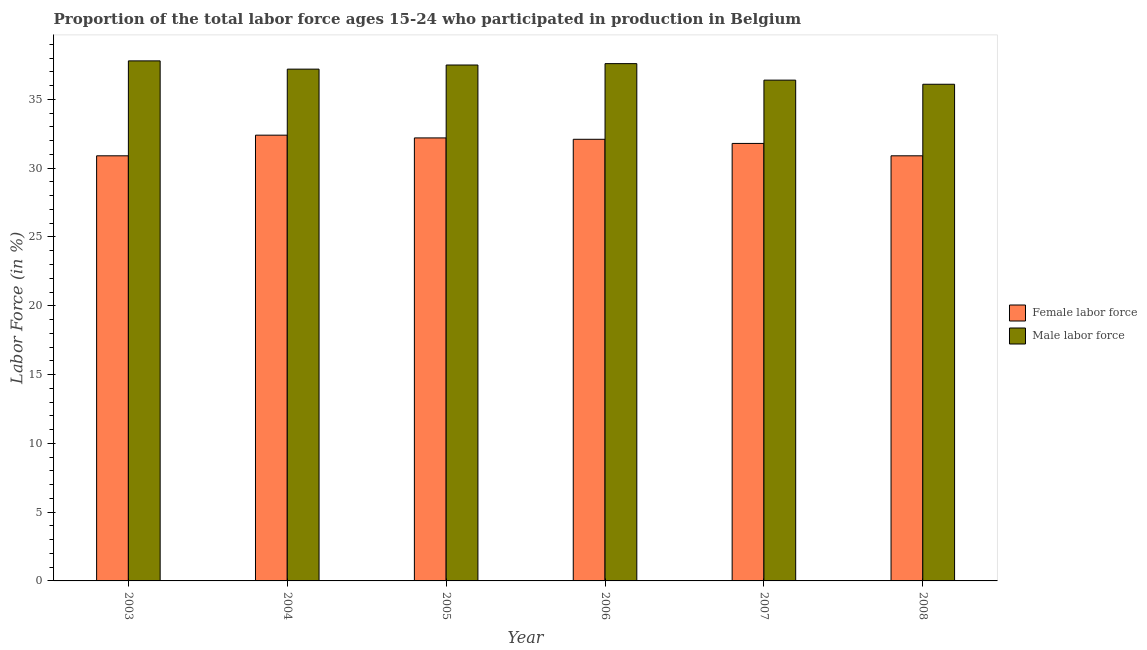How many groups of bars are there?
Provide a short and direct response. 6. Are the number of bars per tick equal to the number of legend labels?
Make the answer very short. Yes. Are the number of bars on each tick of the X-axis equal?
Ensure brevity in your answer.  Yes. How many bars are there on the 3rd tick from the left?
Keep it short and to the point. 2. What is the label of the 6th group of bars from the left?
Provide a short and direct response. 2008. In how many cases, is the number of bars for a given year not equal to the number of legend labels?
Offer a terse response. 0. What is the percentage of male labour force in 2004?
Offer a terse response. 37.2. Across all years, what is the maximum percentage of female labor force?
Keep it short and to the point. 32.4. Across all years, what is the minimum percentage of male labour force?
Make the answer very short. 36.1. In which year was the percentage of male labour force maximum?
Make the answer very short. 2003. In which year was the percentage of female labor force minimum?
Keep it short and to the point. 2003. What is the total percentage of female labor force in the graph?
Your answer should be very brief. 190.3. What is the difference between the percentage of female labor force in 2004 and that in 2005?
Make the answer very short. 0.2. What is the difference between the percentage of female labor force in 2004 and the percentage of male labour force in 2007?
Make the answer very short. 0.6. What is the average percentage of male labour force per year?
Your answer should be very brief. 37.1. In how many years, is the percentage of male labour force greater than 17 %?
Keep it short and to the point. 6. What is the ratio of the percentage of male labour force in 2005 to that in 2007?
Make the answer very short. 1.03. Is the percentage of male labour force in 2003 less than that in 2007?
Give a very brief answer. No. Is the difference between the percentage of female labor force in 2004 and 2006 greater than the difference between the percentage of male labour force in 2004 and 2006?
Provide a short and direct response. No. What is the difference between the highest and the second highest percentage of male labour force?
Your answer should be compact. 0.2. What is the difference between the highest and the lowest percentage of female labor force?
Ensure brevity in your answer.  1.5. Is the sum of the percentage of female labor force in 2004 and 2005 greater than the maximum percentage of male labour force across all years?
Give a very brief answer. Yes. What does the 1st bar from the left in 2005 represents?
Make the answer very short. Female labor force. What does the 1st bar from the right in 2007 represents?
Your answer should be very brief. Male labor force. Are all the bars in the graph horizontal?
Offer a terse response. No. Does the graph contain grids?
Ensure brevity in your answer.  No. Where does the legend appear in the graph?
Your response must be concise. Center right. How many legend labels are there?
Make the answer very short. 2. How are the legend labels stacked?
Provide a short and direct response. Vertical. What is the title of the graph?
Provide a short and direct response. Proportion of the total labor force ages 15-24 who participated in production in Belgium. What is the Labor Force (in %) in Female labor force in 2003?
Offer a very short reply. 30.9. What is the Labor Force (in %) in Male labor force in 2003?
Your answer should be very brief. 37.8. What is the Labor Force (in %) in Female labor force in 2004?
Offer a terse response. 32.4. What is the Labor Force (in %) in Male labor force in 2004?
Offer a terse response. 37.2. What is the Labor Force (in %) of Female labor force in 2005?
Your answer should be very brief. 32.2. What is the Labor Force (in %) of Male labor force in 2005?
Provide a short and direct response. 37.5. What is the Labor Force (in %) in Female labor force in 2006?
Give a very brief answer. 32.1. What is the Labor Force (in %) in Male labor force in 2006?
Your answer should be compact. 37.6. What is the Labor Force (in %) in Female labor force in 2007?
Provide a short and direct response. 31.8. What is the Labor Force (in %) of Male labor force in 2007?
Give a very brief answer. 36.4. What is the Labor Force (in %) in Female labor force in 2008?
Keep it short and to the point. 30.9. What is the Labor Force (in %) in Male labor force in 2008?
Your response must be concise. 36.1. Across all years, what is the maximum Labor Force (in %) in Female labor force?
Provide a succinct answer. 32.4. Across all years, what is the maximum Labor Force (in %) of Male labor force?
Provide a succinct answer. 37.8. Across all years, what is the minimum Labor Force (in %) of Female labor force?
Offer a very short reply. 30.9. Across all years, what is the minimum Labor Force (in %) of Male labor force?
Ensure brevity in your answer.  36.1. What is the total Labor Force (in %) in Female labor force in the graph?
Your answer should be compact. 190.3. What is the total Labor Force (in %) in Male labor force in the graph?
Make the answer very short. 222.6. What is the difference between the Labor Force (in %) of Female labor force in 2003 and that in 2004?
Keep it short and to the point. -1.5. What is the difference between the Labor Force (in %) in Male labor force in 2003 and that in 2004?
Provide a short and direct response. 0.6. What is the difference between the Labor Force (in %) of Female labor force in 2003 and that in 2006?
Your answer should be very brief. -1.2. What is the difference between the Labor Force (in %) of Female labor force in 2003 and that in 2008?
Keep it short and to the point. 0. What is the difference between the Labor Force (in %) of Male labor force in 2003 and that in 2008?
Ensure brevity in your answer.  1.7. What is the difference between the Labor Force (in %) of Male labor force in 2004 and that in 2006?
Keep it short and to the point. -0.4. What is the difference between the Labor Force (in %) in Female labor force in 2004 and that in 2007?
Your answer should be compact. 0.6. What is the difference between the Labor Force (in %) of Male labor force in 2004 and that in 2008?
Keep it short and to the point. 1.1. What is the difference between the Labor Force (in %) of Male labor force in 2005 and that in 2006?
Provide a succinct answer. -0.1. What is the difference between the Labor Force (in %) in Male labor force in 2005 and that in 2007?
Make the answer very short. 1.1. What is the difference between the Labor Force (in %) of Female labor force in 2006 and that in 2007?
Ensure brevity in your answer.  0.3. What is the difference between the Labor Force (in %) in Male labor force in 2006 and that in 2007?
Give a very brief answer. 1.2. What is the difference between the Labor Force (in %) in Male labor force in 2006 and that in 2008?
Keep it short and to the point. 1.5. What is the difference between the Labor Force (in %) in Female labor force in 2003 and the Labor Force (in %) in Male labor force in 2004?
Offer a very short reply. -6.3. What is the difference between the Labor Force (in %) in Female labor force in 2003 and the Labor Force (in %) in Male labor force in 2005?
Provide a short and direct response. -6.6. What is the difference between the Labor Force (in %) of Female labor force in 2003 and the Labor Force (in %) of Male labor force in 2007?
Give a very brief answer. -5.5. What is the difference between the Labor Force (in %) in Female labor force in 2003 and the Labor Force (in %) in Male labor force in 2008?
Your response must be concise. -5.2. What is the difference between the Labor Force (in %) in Female labor force in 2004 and the Labor Force (in %) in Male labor force in 2005?
Offer a very short reply. -5.1. What is the difference between the Labor Force (in %) of Female labor force in 2004 and the Labor Force (in %) of Male labor force in 2006?
Provide a short and direct response. -5.2. What is the difference between the Labor Force (in %) of Female labor force in 2006 and the Labor Force (in %) of Male labor force in 2008?
Your answer should be very brief. -4. What is the average Labor Force (in %) in Female labor force per year?
Offer a very short reply. 31.72. What is the average Labor Force (in %) of Male labor force per year?
Keep it short and to the point. 37.1. In the year 2004, what is the difference between the Labor Force (in %) of Female labor force and Labor Force (in %) of Male labor force?
Offer a terse response. -4.8. In the year 2008, what is the difference between the Labor Force (in %) of Female labor force and Labor Force (in %) of Male labor force?
Your response must be concise. -5.2. What is the ratio of the Labor Force (in %) of Female labor force in 2003 to that in 2004?
Keep it short and to the point. 0.95. What is the ratio of the Labor Force (in %) in Male labor force in 2003 to that in 2004?
Your response must be concise. 1.02. What is the ratio of the Labor Force (in %) of Female labor force in 2003 to that in 2005?
Make the answer very short. 0.96. What is the ratio of the Labor Force (in %) in Female labor force in 2003 to that in 2006?
Ensure brevity in your answer.  0.96. What is the ratio of the Labor Force (in %) of Male labor force in 2003 to that in 2006?
Your answer should be very brief. 1.01. What is the ratio of the Labor Force (in %) of Female labor force in 2003 to that in 2007?
Keep it short and to the point. 0.97. What is the ratio of the Labor Force (in %) of Male labor force in 2003 to that in 2008?
Provide a succinct answer. 1.05. What is the ratio of the Labor Force (in %) in Female labor force in 2004 to that in 2005?
Your answer should be very brief. 1.01. What is the ratio of the Labor Force (in %) of Male labor force in 2004 to that in 2005?
Your answer should be compact. 0.99. What is the ratio of the Labor Force (in %) in Female labor force in 2004 to that in 2006?
Keep it short and to the point. 1.01. What is the ratio of the Labor Force (in %) of Male labor force in 2004 to that in 2006?
Offer a terse response. 0.99. What is the ratio of the Labor Force (in %) of Female labor force in 2004 to that in 2007?
Keep it short and to the point. 1.02. What is the ratio of the Labor Force (in %) of Female labor force in 2004 to that in 2008?
Provide a short and direct response. 1.05. What is the ratio of the Labor Force (in %) in Male labor force in 2004 to that in 2008?
Ensure brevity in your answer.  1.03. What is the ratio of the Labor Force (in %) in Female labor force in 2005 to that in 2006?
Provide a succinct answer. 1. What is the ratio of the Labor Force (in %) of Male labor force in 2005 to that in 2006?
Provide a short and direct response. 1. What is the ratio of the Labor Force (in %) of Female labor force in 2005 to that in 2007?
Your answer should be very brief. 1.01. What is the ratio of the Labor Force (in %) of Male labor force in 2005 to that in 2007?
Provide a succinct answer. 1.03. What is the ratio of the Labor Force (in %) of Female labor force in 2005 to that in 2008?
Ensure brevity in your answer.  1.04. What is the ratio of the Labor Force (in %) of Male labor force in 2005 to that in 2008?
Offer a terse response. 1.04. What is the ratio of the Labor Force (in %) of Female labor force in 2006 to that in 2007?
Your answer should be compact. 1.01. What is the ratio of the Labor Force (in %) in Male labor force in 2006 to that in 2007?
Offer a very short reply. 1.03. What is the ratio of the Labor Force (in %) in Female labor force in 2006 to that in 2008?
Make the answer very short. 1.04. What is the ratio of the Labor Force (in %) of Male labor force in 2006 to that in 2008?
Provide a short and direct response. 1.04. What is the ratio of the Labor Force (in %) of Female labor force in 2007 to that in 2008?
Keep it short and to the point. 1.03. What is the ratio of the Labor Force (in %) in Male labor force in 2007 to that in 2008?
Your response must be concise. 1.01. What is the difference between the highest and the second highest Labor Force (in %) in Male labor force?
Make the answer very short. 0.2. What is the difference between the highest and the lowest Labor Force (in %) of Male labor force?
Offer a terse response. 1.7. 